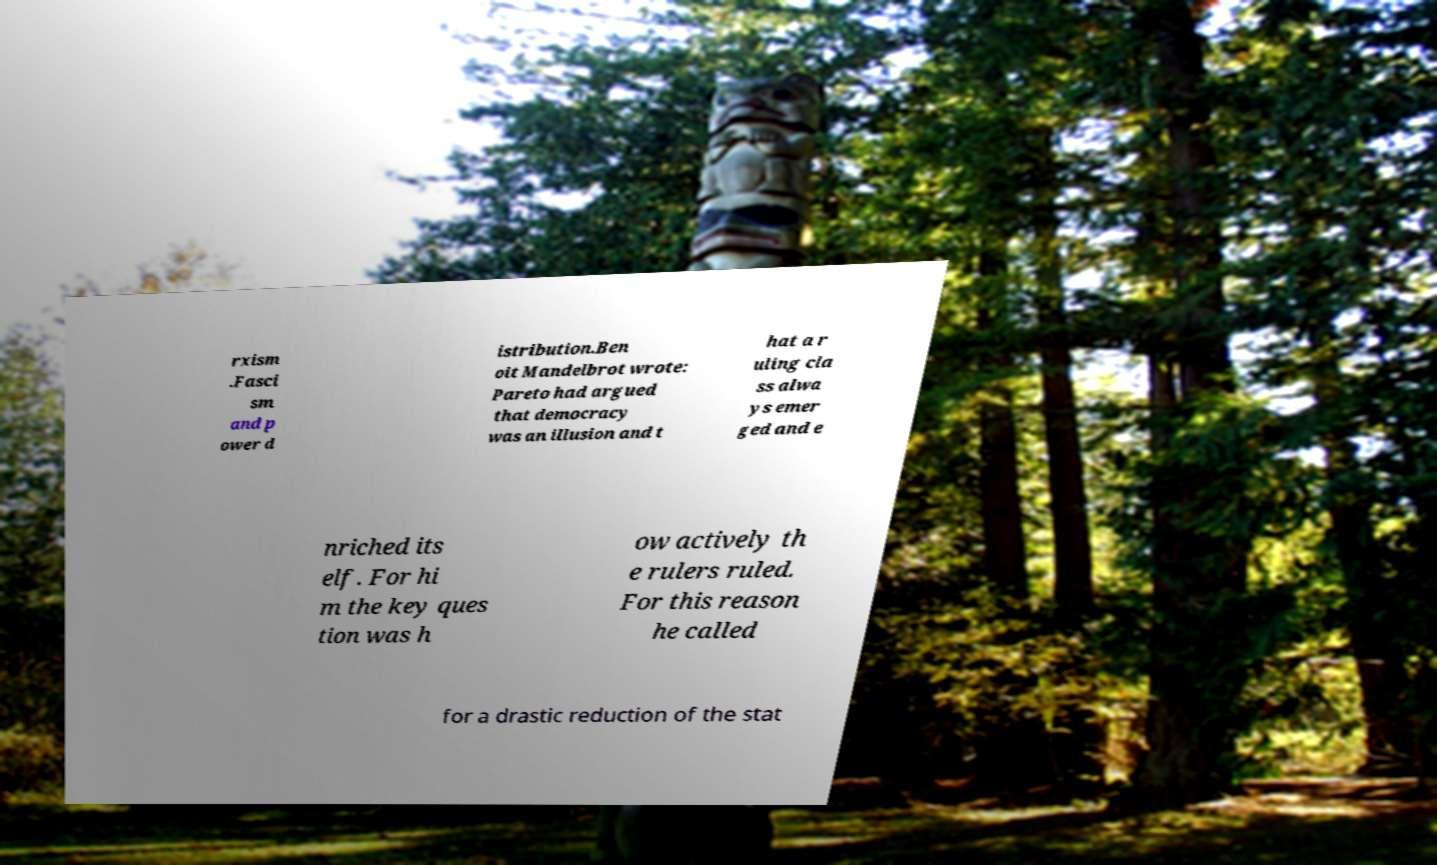Can you accurately transcribe the text from the provided image for me? rxism .Fasci sm and p ower d istribution.Ben oit Mandelbrot wrote: Pareto had argued that democracy was an illusion and t hat a r uling cla ss alwa ys emer ged and e nriched its elf. For hi m the key ques tion was h ow actively th e rulers ruled. For this reason he called for a drastic reduction of the stat 